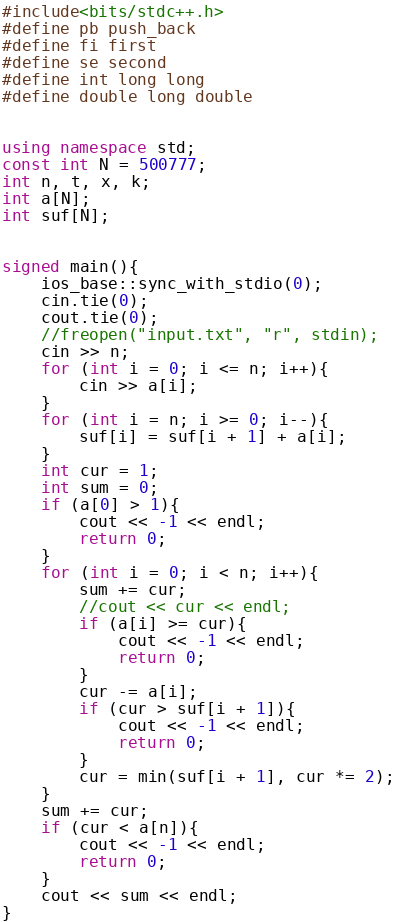Convert code to text. <code><loc_0><loc_0><loc_500><loc_500><_C++_>#include<bits/stdc++.h>
#define pb push_back
#define fi first
#define se second
#define int long long
#define double long double


using namespace std;
const int N = 500777;
int n, t, x, k;
int a[N];
int suf[N];


signed main(){
    ios_base::sync_with_stdio(0);
    cin.tie(0);
    cout.tie(0);
	//freopen("input.txt", "r", stdin);
    cin >> n;
    for (int i = 0; i <= n; i++){
        cin >> a[i];
    }
    for (int i = n; i >= 0; i--){
        suf[i] = suf[i + 1] + a[i];
    }
    int cur = 1;
    int sum = 0;
    if (a[0] > 1){
        cout << -1 << endl;
        return 0;
    }
    for (int i = 0; i < n; i++){
        sum += cur;
        //cout << cur << endl;
        if (a[i] >= cur){
            cout << -1 << endl;
            return 0;
        }
        cur -= a[i];
        if (cur > suf[i + 1]){
            cout << -1 << endl;
            return 0;
        }
        cur = min(suf[i + 1], cur *= 2);
    }
    sum += cur;
    if (cur < a[n]){
        cout << -1 << endl;
        return 0;
    }
    cout << sum << endl;
}
</code> 